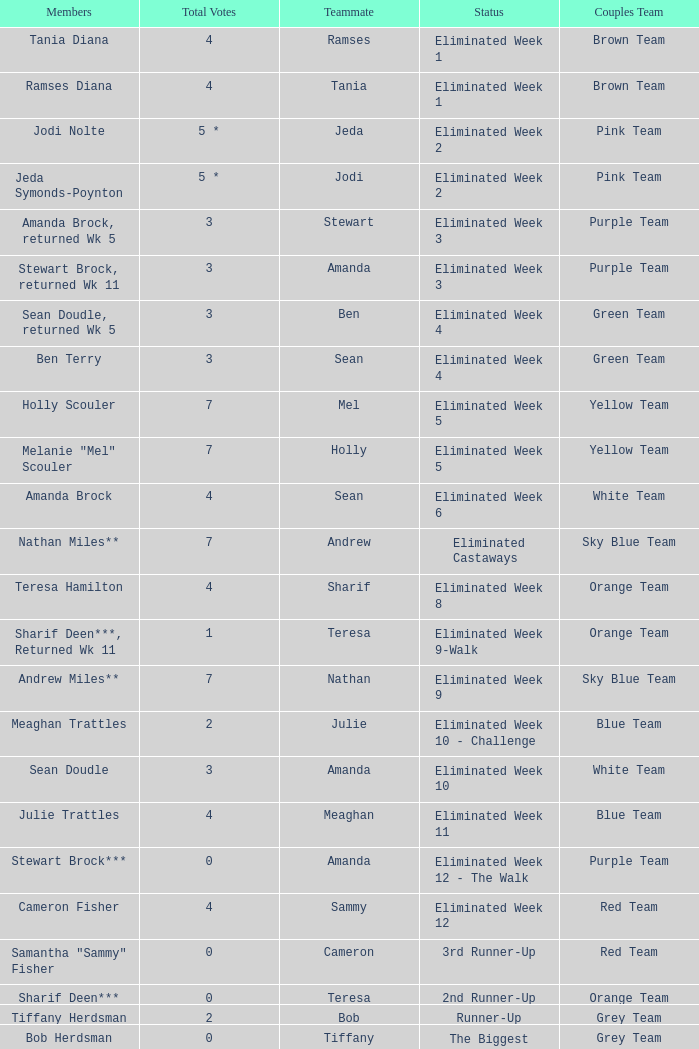What was Holly Scouler's total votes 7.0. 